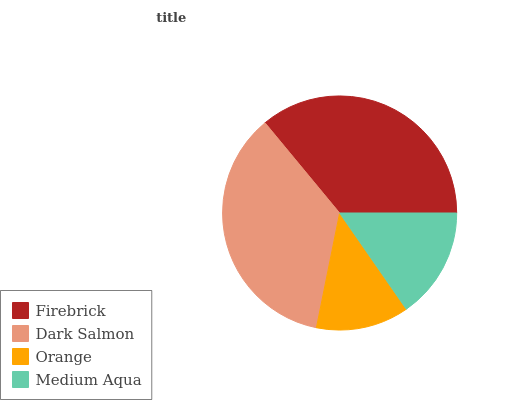Is Orange the minimum?
Answer yes or no. Yes. Is Firebrick the maximum?
Answer yes or no. Yes. Is Dark Salmon the minimum?
Answer yes or no. No. Is Dark Salmon the maximum?
Answer yes or no. No. Is Firebrick greater than Dark Salmon?
Answer yes or no. Yes. Is Dark Salmon less than Firebrick?
Answer yes or no. Yes. Is Dark Salmon greater than Firebrick?
Answer yes or no. No. Is Firebrick less than Dark Salmon?
Answer yes or no. No. Is Dark Salmon the high median?
Answer yes or no. Yes. Is Medium Aqua the low median?
Answer yes or no. Yes. Is Orange the high median?
Answer yes or no. No. Is Firebrick the low median?
Answer yes or no. No. 